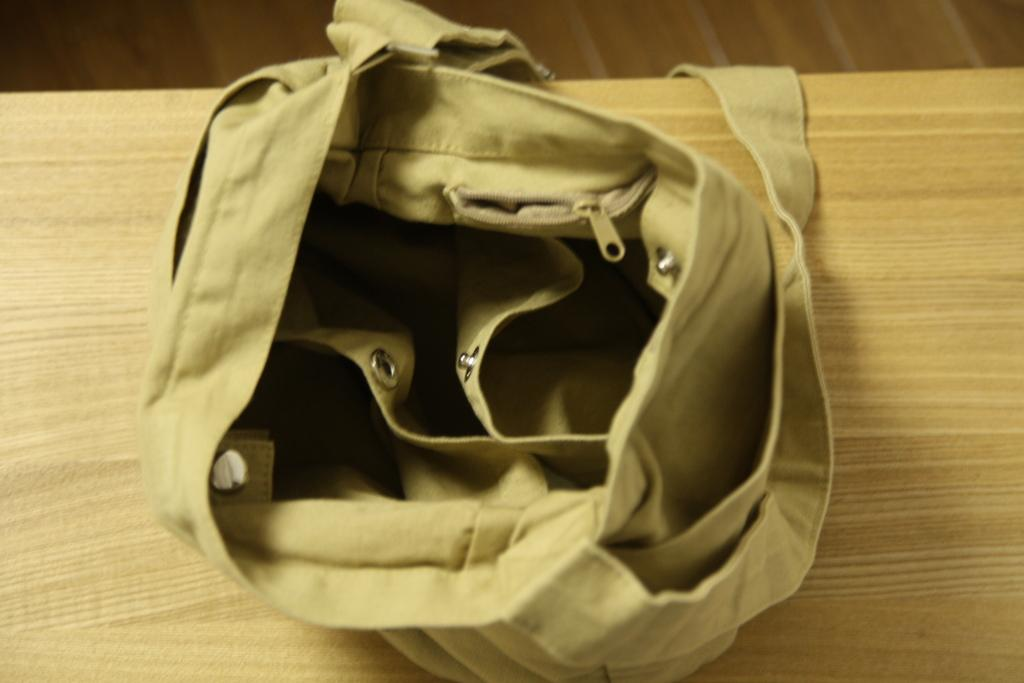What piece of furniture is present in the image? There is a table in the image. What color is the table? The table is yellow. What object is placed on the table? There is a bag on the table. What color is the bag? The bag is yellow. What can be seen in the background of the image? The background of the image includes a floor. What color is the floor? The floor is brown. Can you find the receipt for the purchase of the skate in the image? There is no skate or receipt present in the image. What type of parcel is being delivered in the image? There is no parcel being delivered in the image. 